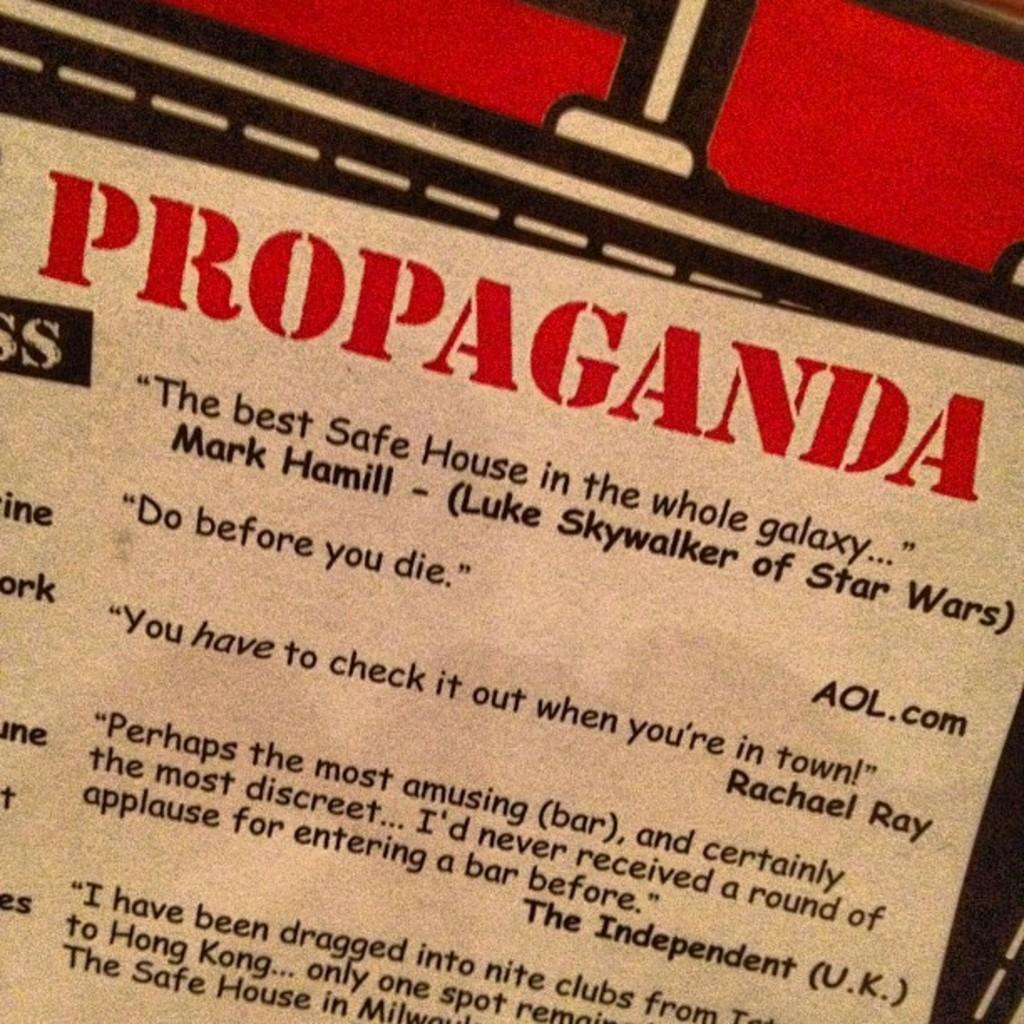<image>
Relay a brief, clear account of the picture shown. Appears to be a flyer with reviews for a movie called Safe House. 